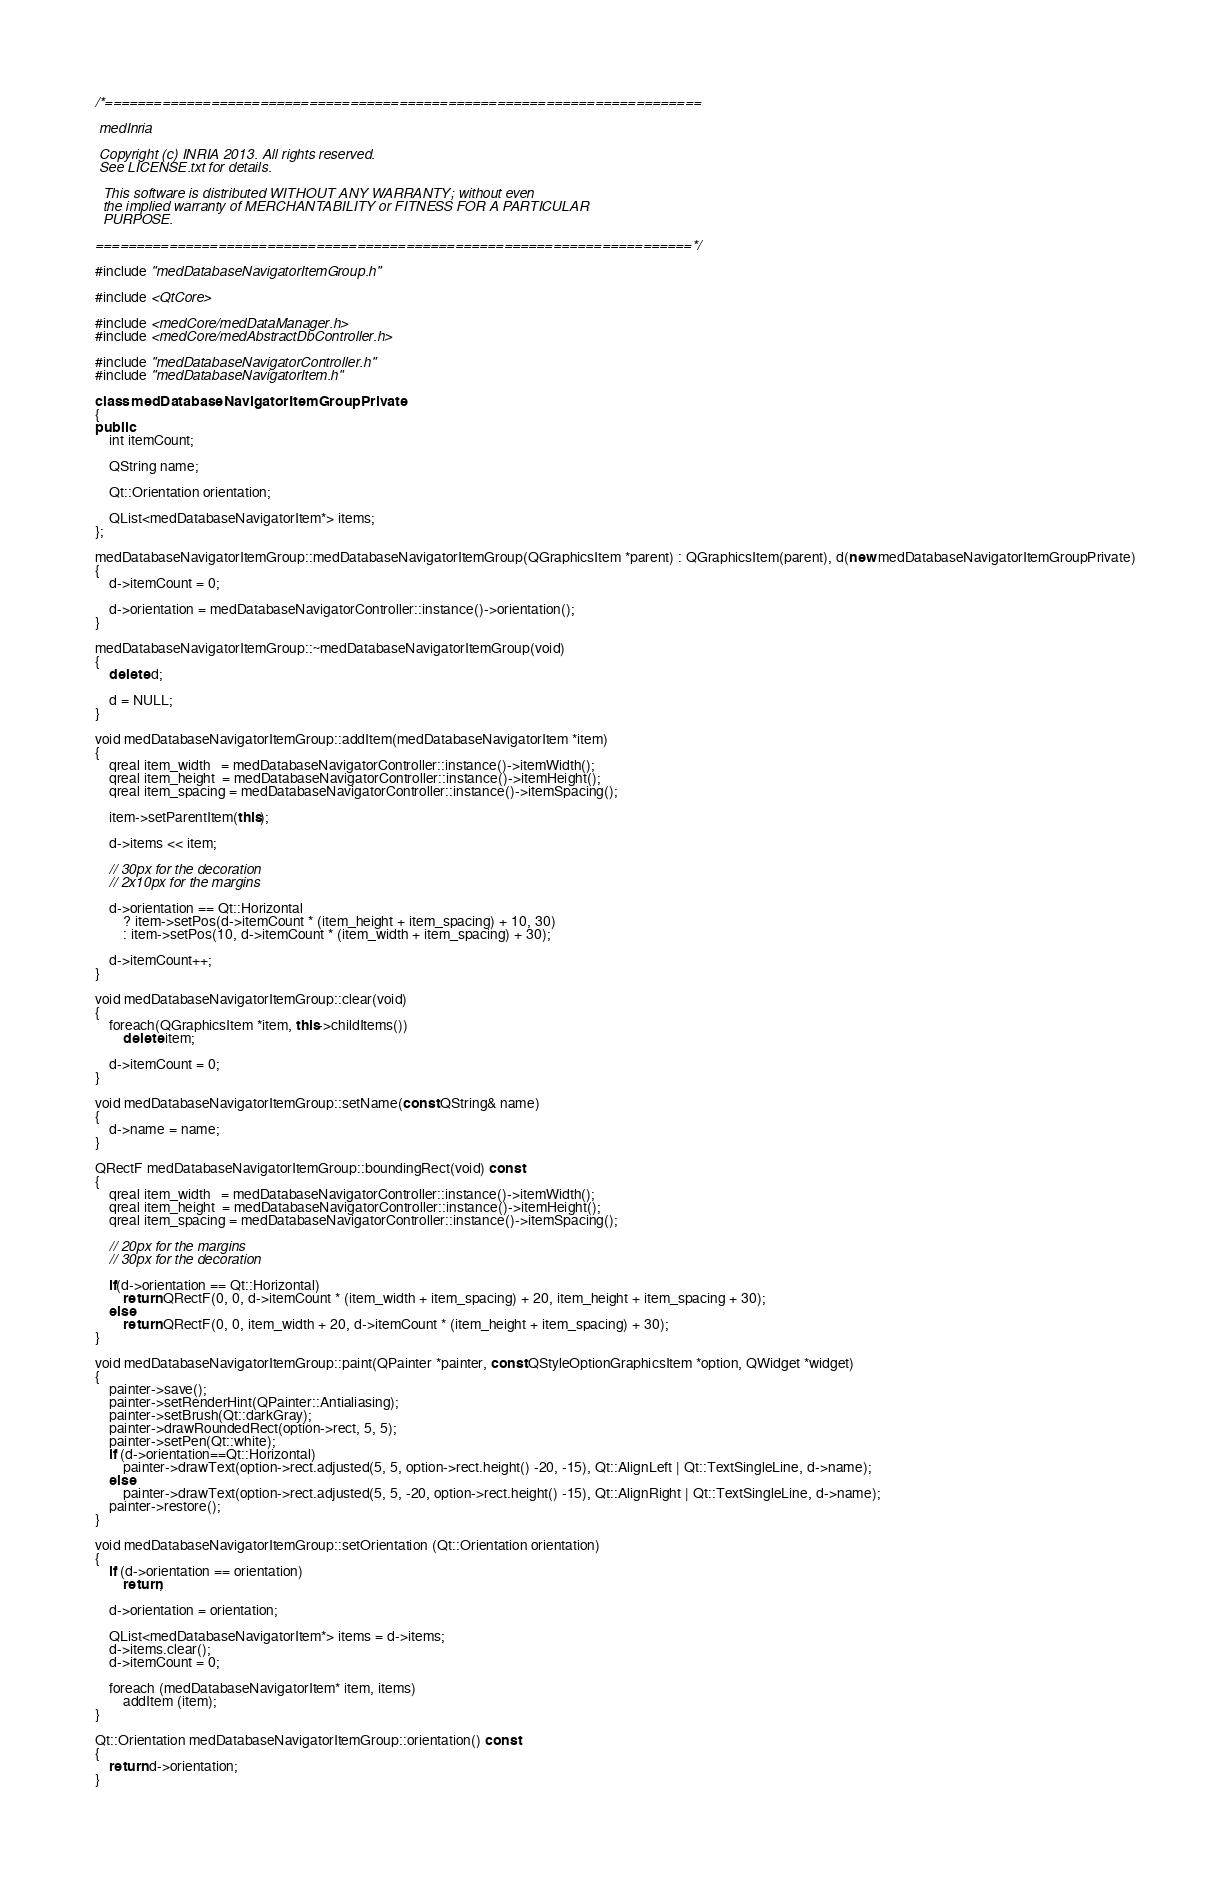<code> <loc_0><loc_0><loc_500><loc_500><_C++_>/*=========================================================================

 medInria

 Copyright (c) INRIA 2013. All rights reserved.
 See LICENSE.txt for details.
 
  This software is distributed WITHOUT ANY WARRANTY; without even
  the implied warranty of MERCHANTABILITY or FITNESS FOR A PARTICULAR
  PURPOSE.

=========================================================================*/

#include "medDatabaseNavigatorItemGroup.h"

#include <QtCore>

#include <medCore/medDataManager.h>
#include <medCore/medAbstractDbController.h>

#include "medDatabaseNavigatorController.h"
#include "medDatabaseNavigatorItem.h"

class medDatabaseNavigatorItemGroupPrivate
{
public:
    int itemCount;

    QString name;

    Qt::Orientation orientation;

    QList<medDatabaseNavigatorItem*> items;
};

medDatabaseNavigatorItemGroup::medDatabaseNavigatorItemGroup(QGraphicsItem *parent) : QGraphicsItem(parent), d(new medDatabaseNavigatorItemGroupPrivate)
{
    d->itemCount = 0;

    d->orientation = medDatabaseNavigatorController::instance()->orientation();
}

medDatabaseNavigatorItemGroup::~medDatabaseNavigatorItemGroup(void)
{
    delete d;

    d = NULL;
}

void medDatabaseNavigatorItemGroup::addItem(medDatabaseNavigatorItem *item)
{
    qreal item_width   = medDatabaseNavigatorController::instance()->itemWidth();
    qreal item_height  = medDatabaseNavigatorController::instance()->itemHeight();
    qreal item_spacing = medDatabaseNavigatorController::instance()->itemSpacing();

    item->setParentItem(this);

    d->items << item;

    // 30px for the decoration
    // 2x10px for the margins

    d->orientation == Qt::Horizontal
        ? item->setPos(d->itemCount * (item_height + item_spacing) + 10, 30)
        : item->setPos(10, d->itemCount * (item_width + item_spacing) + 30);

    d->itemCount++;
}

void medDatabaseNavigatorItemGroup::clear(void)
{
    foreach(QGraphicsItem *item, this->childItems())
        delete item;

    d->itemCount = 0;
}

void medDatabaseNavigatorItemGroup::setName(const QString& name)
{
    d->name = name;
}

QRectF medDatabaseNavigatorItemGroup::boundingRect(void) const
{
    qreal item_width   = medDatabaseNavigatorController::instance()->itemWidth();
    qreal item_height  = medDatabaseNavigatorController::instance()->itemHeight();
    qreal item_spacing = medDatabaseNavigatorController::instance()->itemSpacing();

    // 20px for the margins
    // 30px for the decoration

    if(d->orientation == Qt::Horizontal)
        return QRectF(0, 0, d->itemCount * (item_width + item_spacing) + 20, item_height + item_spacing + 30);
    else
        return QRectF(0, 0, item_width + 20, d->itemCount * (item_height + item_spacing) + 30);
}

void medDatabaseNavigatorItemGroup::paint(QPainter *painter, const QStyleOptionGraphicsItem *option, QWidget *widget)
{
    painter->save();
    painter->setRenderHint(QPainter::Antialiasing);
    painter->setBrush(Qt::darkGray);
    painter->drawRoundedRect(option->rect, 5, 5);
    painter->setPen(Qt::white);
    if (d->orientation==Qt::Horizontal)
        painter->drawText(option->rect.adjusted(5, 5, option->rect.height() -20, -15), Qt::AlignLeft | Qt::TextSingleLine, d->name);
    else
        painter->drawText(option->rect.adjusted(5, 5, -20, option->rect.height() -15), Qt::AlignRight | Qt::TextSingleLine, d->name);
    painter->restore();
}

void medDatabaseNavigatorItemGroup::setOrientation (Qt::Orientation orientation)
{
    if (d->orientation == orientation)
        return;

    d->orientation = orientation;

    QList<medDatabaseNavigatorItem*> items = d->items;
    d->items.clear();
    d->itemCount = 0;

    foreach (medDatabaseNavigatorItem* item, items)
        addItem (item);
}

Qt::Orientation medDatabaseNavigatorItemGroup::orientation() const
{
    return d->orientation;
}
</code> 